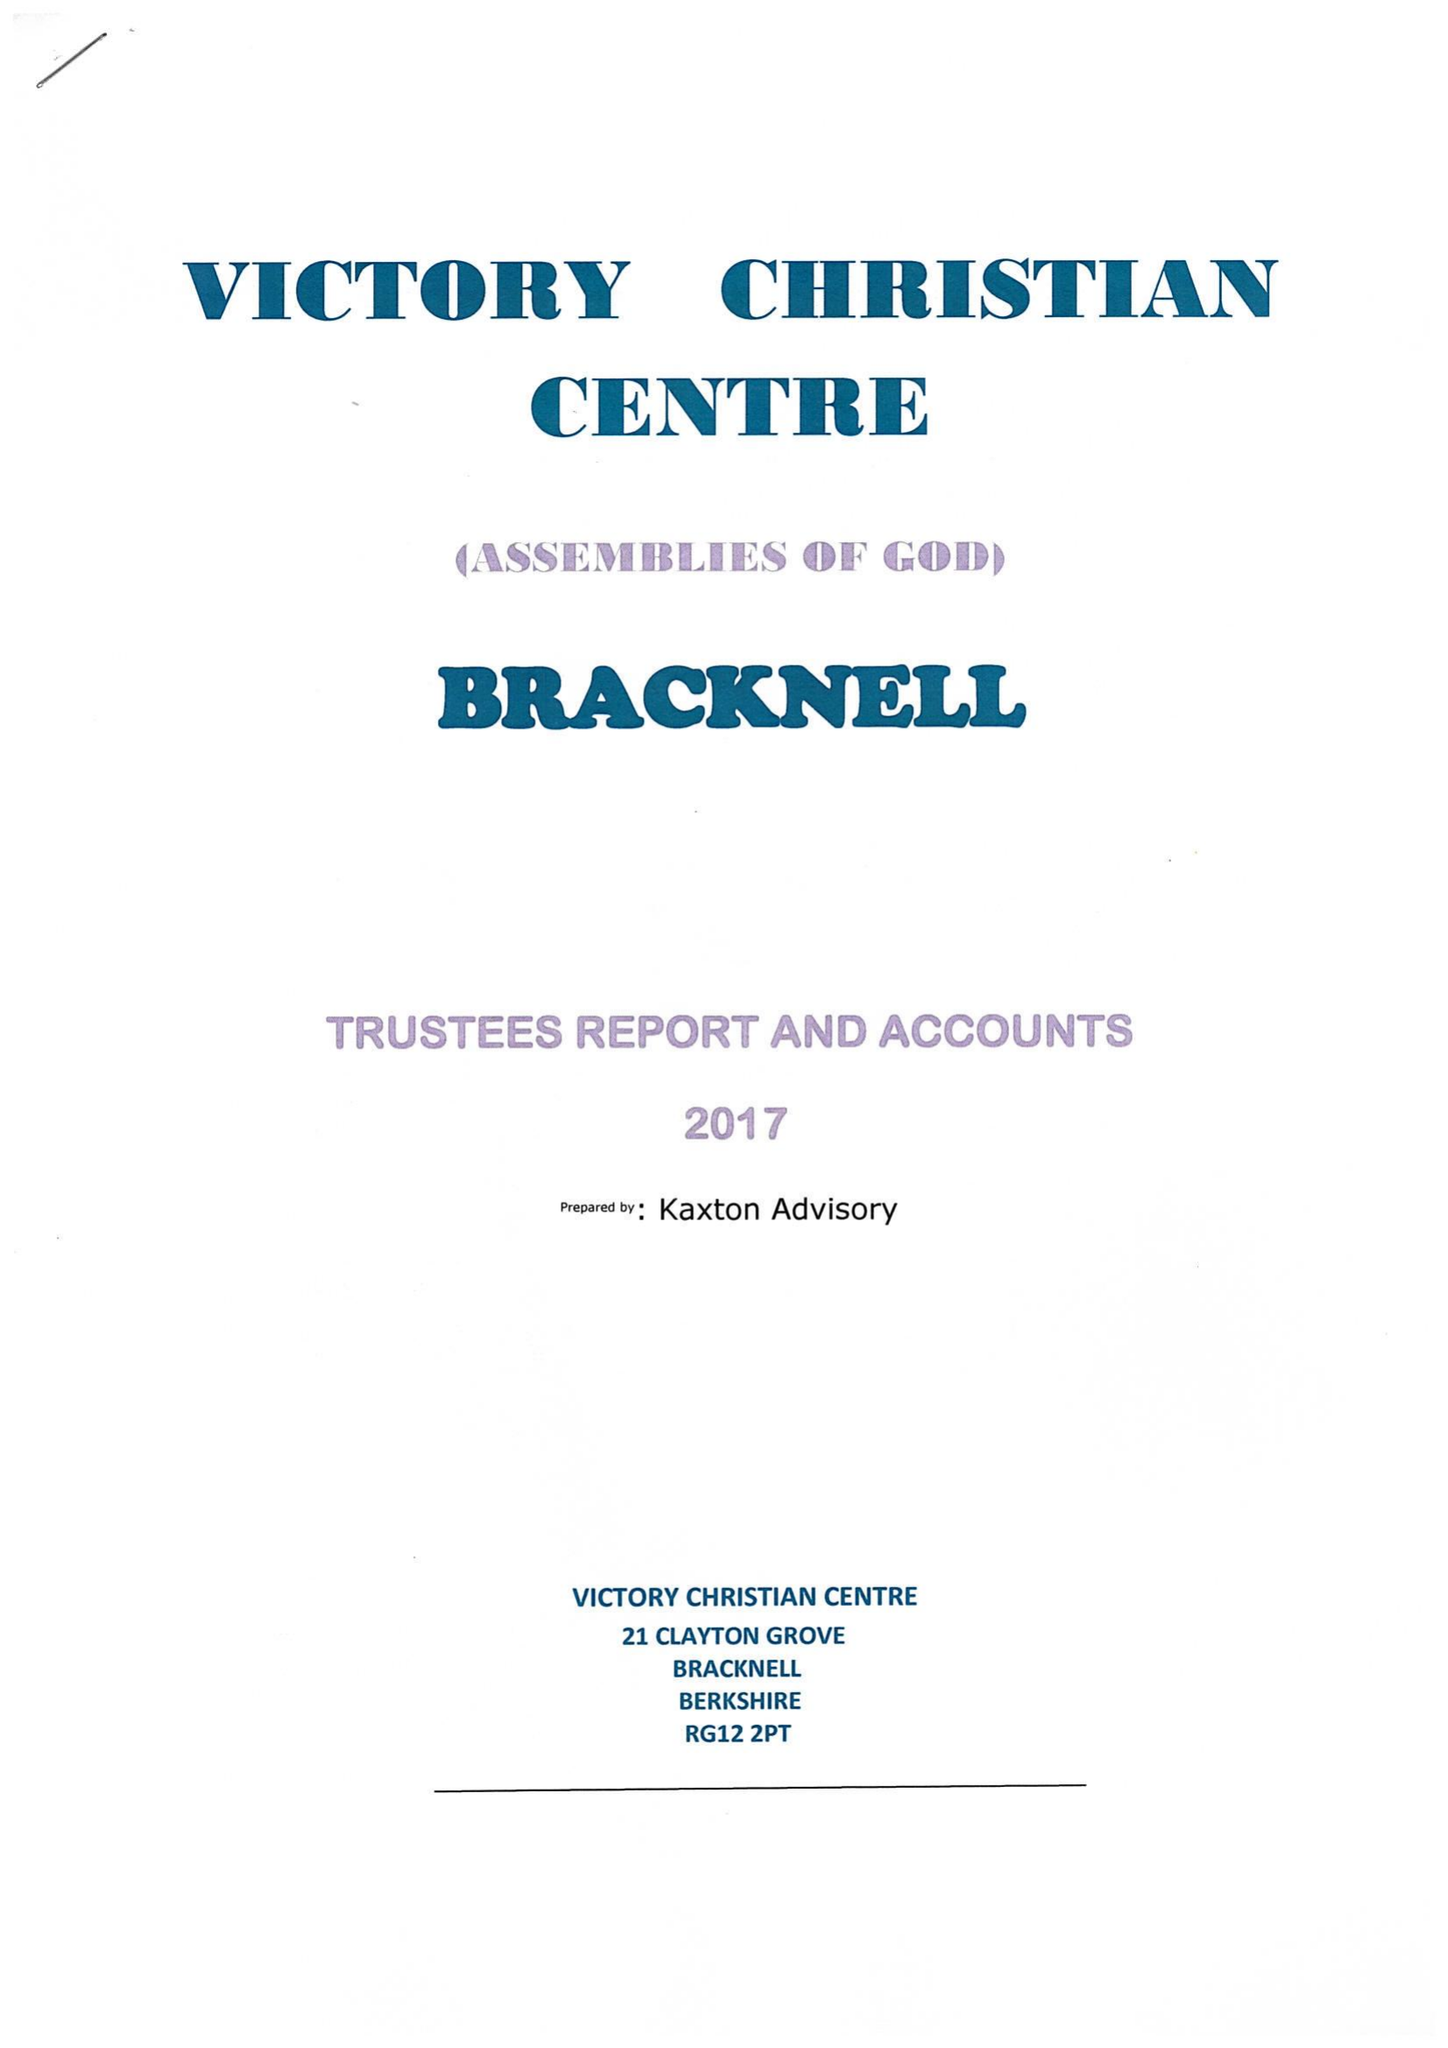What is the value for the income_annually_in_british_pounds?
Answer the question using a single word or phrase. 50507.00 